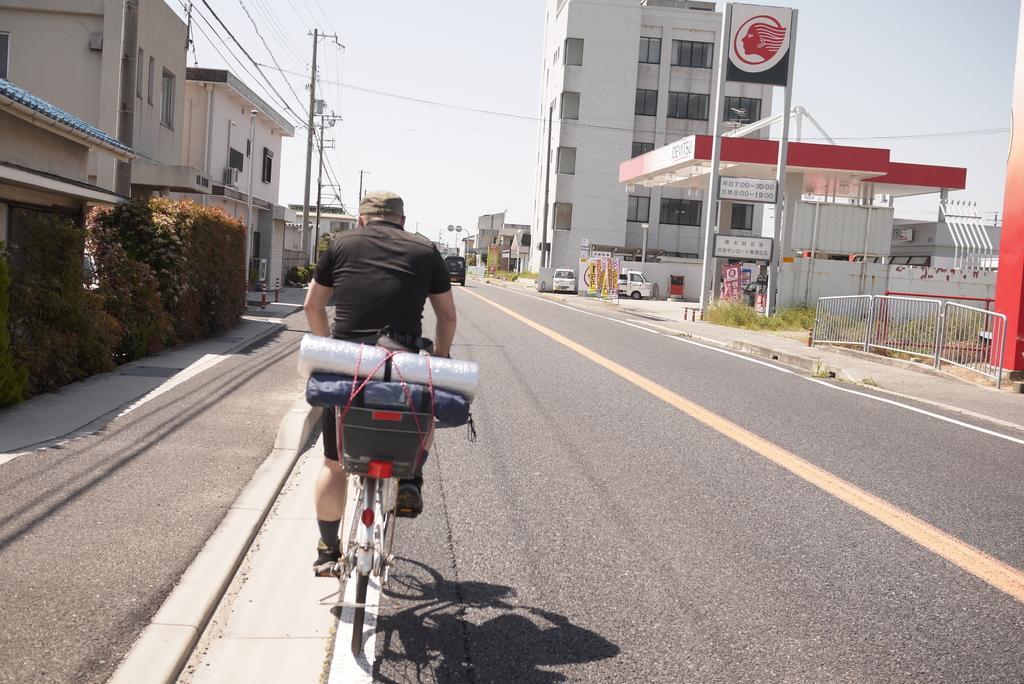Could you give a brief overview of what you see in this image? In this image I can see a man is sitting on a bicycle. On the bicycle I can see some objects. In the background I can see vehicles, buildings, poles which has wires. Here I can see a petrol pump, the grass, plants and other objects on the ground. In the background I can see the sky. 